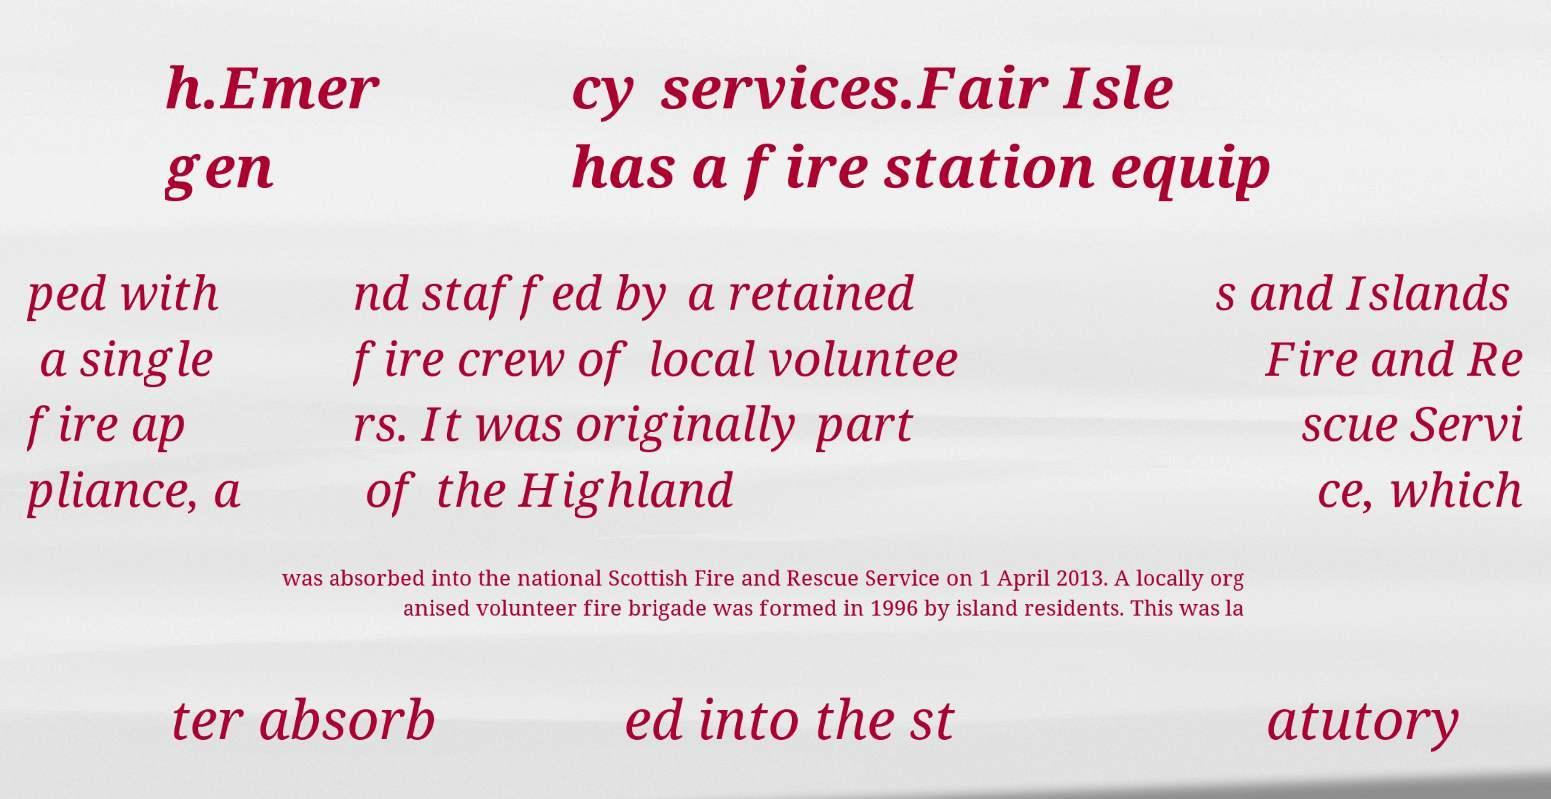Please read and relay the text visible in this image. What does it say? h.Emer gen cy services.Fair Isle has a fire station equip ped with a single fire ap pliance, a nd staffed by a retained fire crew of local voluntee rs. It was originally part of the Highland s and Islands Fire and Re scue Servi ce, which was absorbed into the national Scottish Fire and Rescue Service on 1 April 2013. A locally org anised volunteer fire brigade was formed in 1996 by island residents. This was la ter absorb ed into the st atutory 